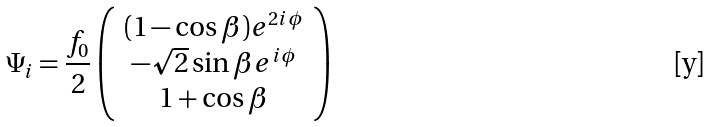Convert formula to latex. <formula><loc_0><loc_0><loc_500><loc_500>\Psi _ { i } = \frac { f _ { 0 } } { 2 } \left ( \begin{array} { c } ( 1 - \cos \beta ) e ^ { 2 i \phi } \\ - { \sqrt { 2 } } \sin \beta e ^ { i \phi } \\ 1 + \cos \beta \end{array} \right )</formula> 